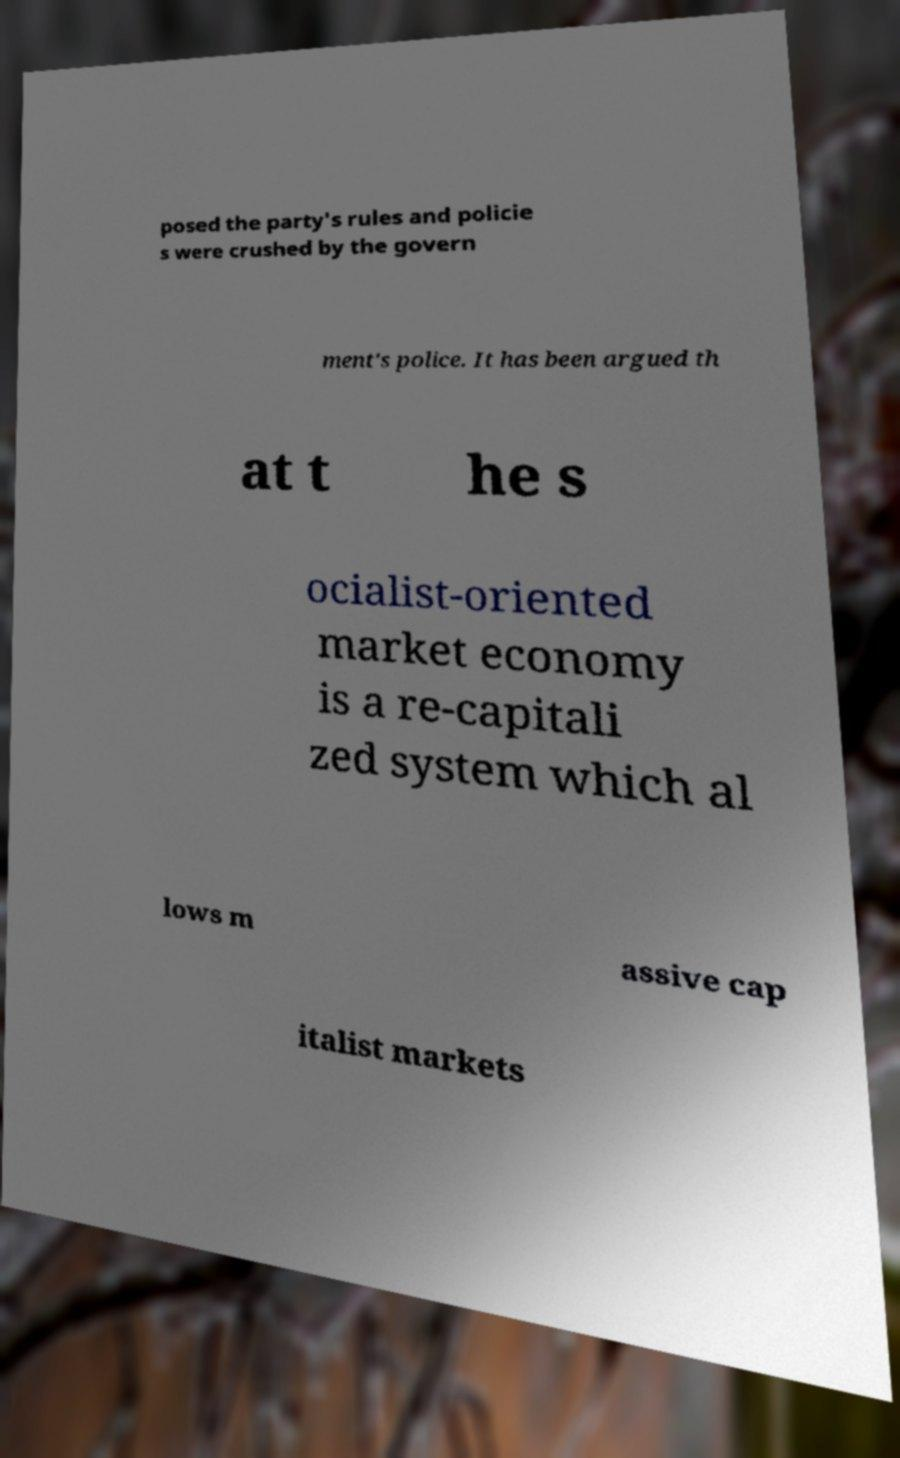For documentation purposes, I need the text within this image transcribed. Could you provide that? posed the party's rules and policie s were crushed by the govern ment's police. It has been argued th at t he s ocialist-oriented market economy is a re-capitali zed system which al lows m assive cap italist markets 